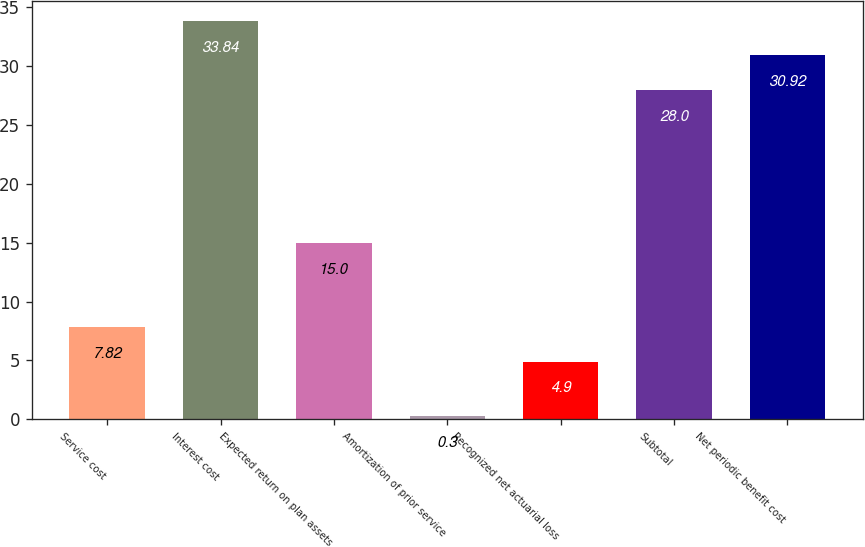Convert chart to OTSL. <chart><loc_0><loc_0><loc_500><loc_500><bar_chart><fcel>Service cost<fcel>Interest cost<fcel>Expected return on plan assets<fcel>Amortization of prior service<fcel>Recognized net actuarial loss<fcel>Subtotal<fcel>Net periodic benefit cost<nl><fcel>7.82<fcel>33.84<fcel>15<fcel>0.3<fcel>4.9<fcel>28<fcel>30.92<nl></chart> 